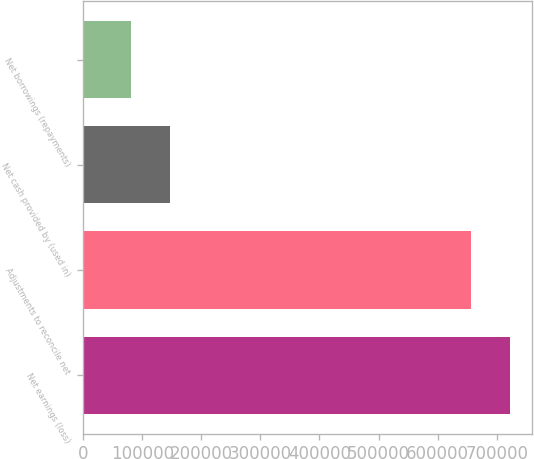Convert chart to OTSL. <chart><loc_0><loc_0><loc_500><loc_500><bar_chart><fcel>Net earnings (loss)<fcel>Adjustments to reconcile net<fcel>Net cash provided by (used in)<fcel>Net borrowings (repayments)<nl><fcel>722858<fcel>657144<fcel>146415<fcel>80700.4<nl></chart> 